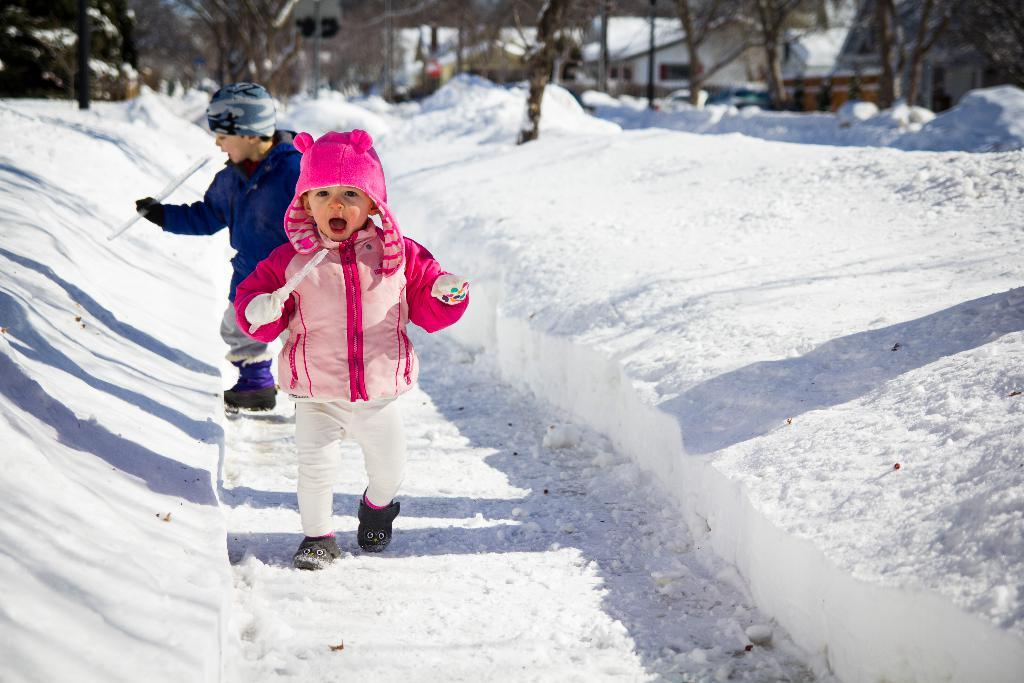What is the condition of the ground in the image? There is snow on the ground in the image. How many children are present in the image? There are two children in the image. What are the children wearing on their heads? The children are wearing caps in the image. What are the children holding in their hands? The children are holding something in their hands, but the specific object is not mentioned in the facts. What can be seen in the background of the image? There are trees and buildings in the background of the image. What type of badge is the child wearing on their shirt in the image? There is no mention of a badge in the image, so it cannot be determined if a child is wearing one. What type of business is being conducted in the image? There is no indication of any business activity in the image. 